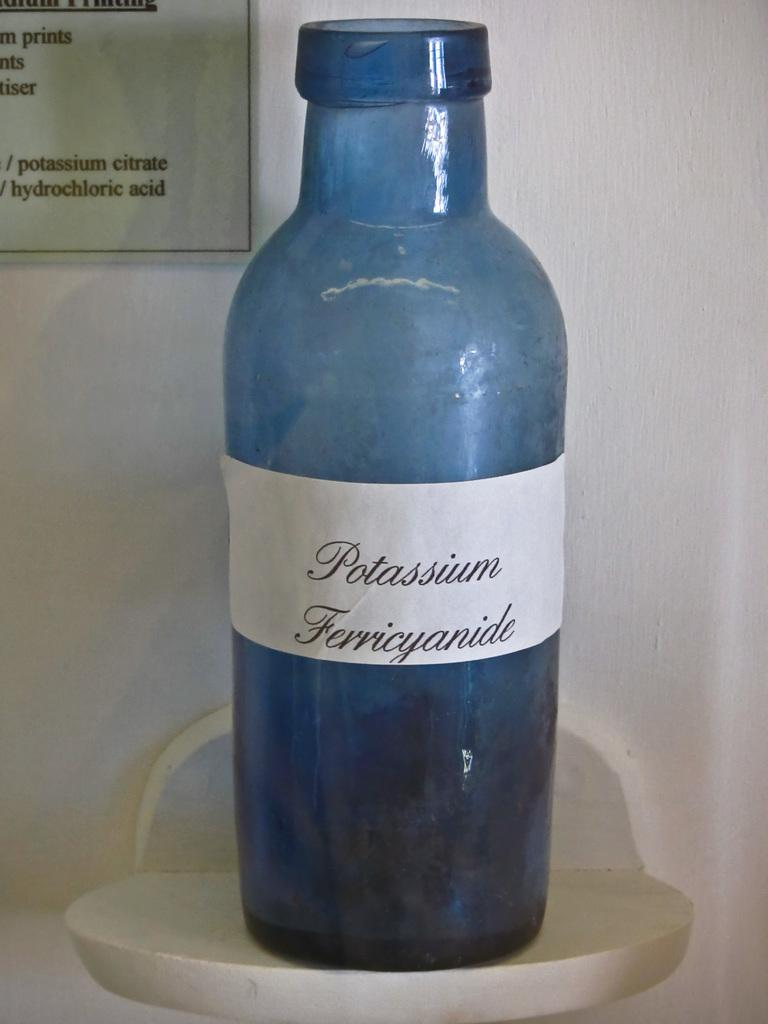<image>
Summarize the visual content of the image. A blue bottle on display is labelled "potassium ferricyanide" 